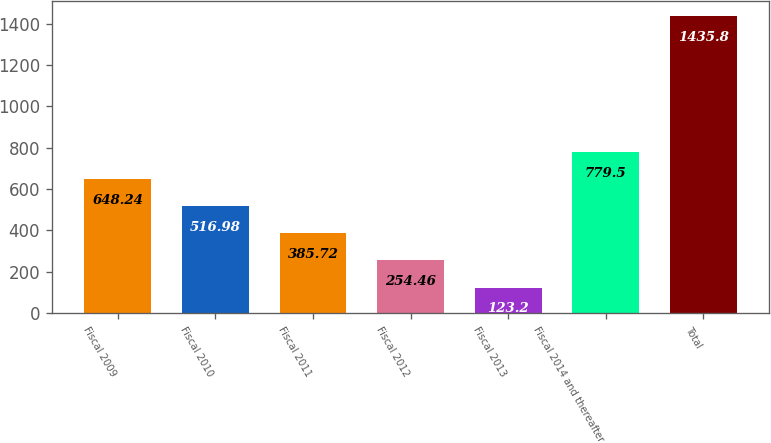Convert chart. <chart><loc_0><loc_0><loc_500><loc_500><bar_chart><fcel>Fiscal 2009<fcel>Fiscal 2010<fcel>Fiscal 2011<fcel>Fiscal 2012<fcel>Fiscal 2013<fcel>Fiscal 2014 and thereafter<fcel>Total<nl><fcel>648.24<fcel>516.98<fcel>385.72<fcel>254.46<fcel>123.2<fcel>779.5<fcel>1435.8<nl></chart> 